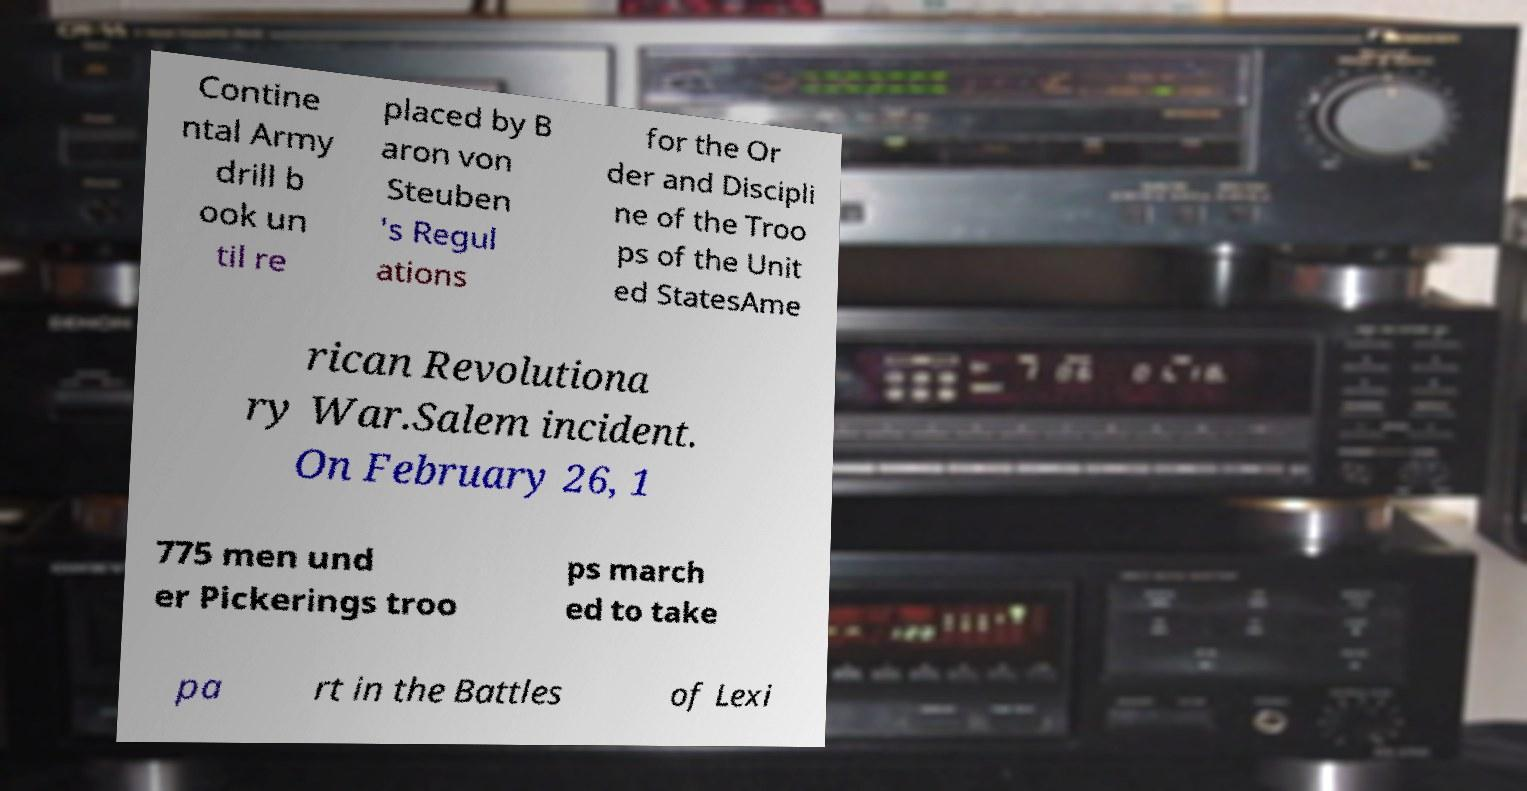What messages or text are displayed in this image? I need them in a readable, typed format. Contine ntal Army drill b ook un til re placed by B aron von Steuben 's Regul ations for the Or der and Discipli ne of the Troo ps of the Unit ed StatesAme rican Revolutiona ry War.Salem incident. On February 26, 1 775 men und er Pickerings troo ps march ed to take pa rt in the Battles of Lexi 